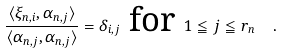Convert formula to latex. <formula><loc_0><loc_0><loc_500><loc_500>\frac { \langle \xi _ { n , i } , \alpha _ { n , j } \rangle } { \langle \alpha _ { n , j } , \alpha _ { n , j } \rangle } = \delta _ { i , j } \text { for } 1 \leqq j \leqq r _ { n } \ \ .</formula> 